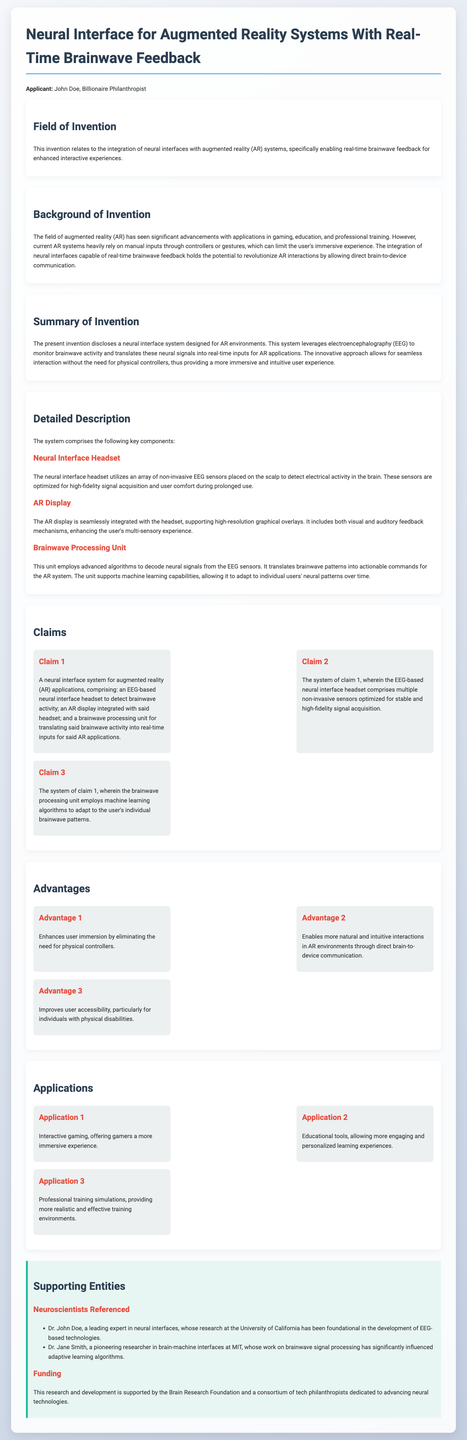What is the name of the applicant? The applicant's name is stated at the beginning of the document in the applicant section.
Answer: John Doe What technology does the neural interface system utilize? The background of the invention mentions the technology used in the neural interface system, specifically related to brain activity measurement.
Answer: Electroencephalography (EEG) How many claims are listed in the claims section? The claims section describes the number of distinct claims made regarding the invention.
Answer: Three Which university is Dr. John Doe associated with? The supporting entities section provides the details of Dr. John Doe's association in relation to his expertise in neural interfaces.
Answer: University of California What is one advantage of the neural interface system mentioned in the document? The advantages section outlines several benefits of the technology, illustrating its impact on user interaction.
Answer: Enhances user immersion What application is highlighted for interactive gaming? The applications section lists various uses for the technology, specifically mentioning gaming as one of the main areas.
Answer: Offering gamers a more immersive experience What year is the research supported by the Brain Research Foundation? The document does not specify a year directly; hence, this is an implicit inquiry about temporal context.
Answer: The document does not provide a year What type of signals does the brainwave processing unit decode? The detailed description of the system clarifies the nature of the signals that the processing unit translates for the AR application.
Answer: Neural signals What is the purpose of the neural interface headset? The detailed description section specifies the functionality of the headset in detecting brain activity.
Answer: To detect brainwave activity 